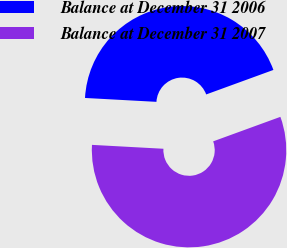<chart> <loc_0><loc_0><loc_500><loc_500><pie_chart><fcel>Balance at December 31 2006<fcel>Balance at December 31 2007<nl><fcel>43.57%<fcel>56.43%<nl></chart> 